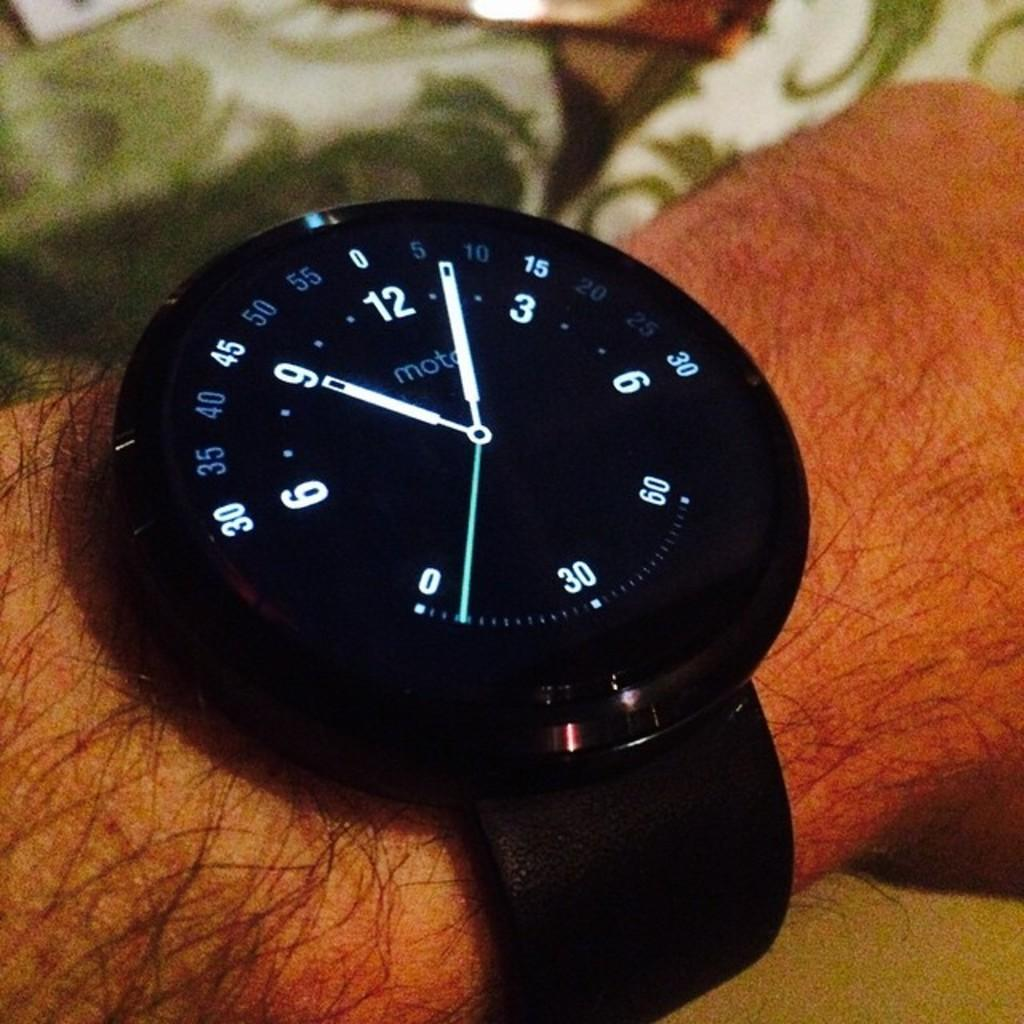<image>
Relay a brief, clear account of the picture shown. A man with a slightly hairy are is wearing a Mota wrist watch that reads the time as 9:06. 